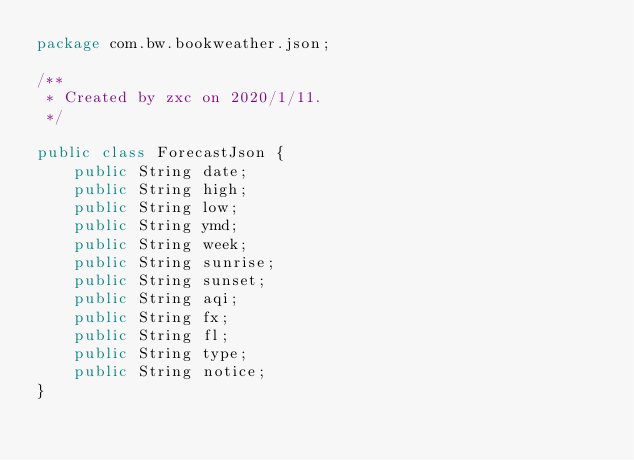<code> <loc_0><loc_0><loc_500><loc_500><_Java_>package com.bw.bookweather.json;

/**
 * Created by zxc on 2020/1/11.
 */

public class ForecastJson {
    public String date;
    public String high;
    public String low;
    public String ymd;
    public String week;
    public String sunrise;
    public String sunset;
    public String aqi;
    public String fx;
    public String fl;
    public String type;
    public String notice;
}
</code> 